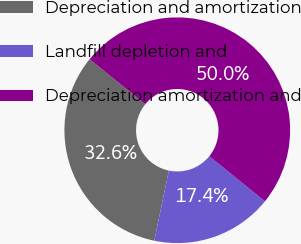Convert chart to OTSL. <chart><loc_0><loc_0><loc_500><loc_500><pie_chart><fcel>Depreciation and amortization<fcel>Landfill depletion and<fcel>Depreciation amortization and<nl><fcel>32.57%<fcel>17.43%<fcel>50.0%<nl></chart> 